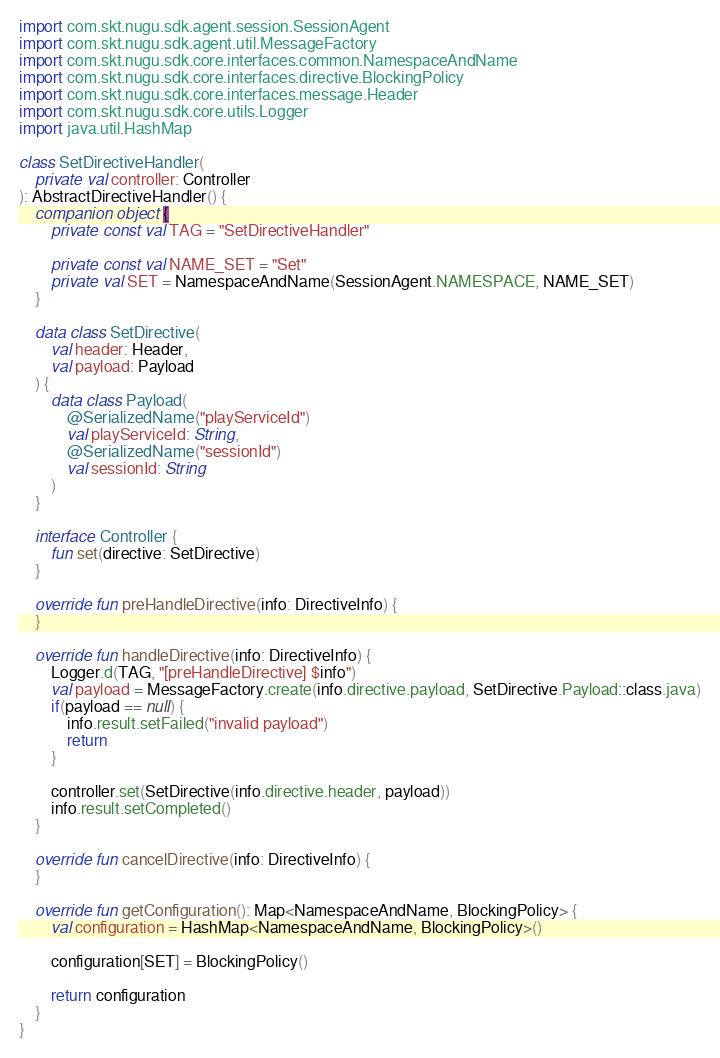<code> <loc_0><loc_0><loc_500><loc_500><_Kotlin_>import com.skt.nugu.sdk.agent.session.SessionAgent
import com.skt.nugu.sdk.agent.util.MessageFactory
import com.skt.nugu.sdk.core.interfaces.common.NamespaceAndName
import com.skt.nugu.sdk.core.interfaces.directive.BlockingPolicy
import com.skt.nugu.sdk.core.interfaces.message.Header
import com.skt.nugu.sdk.core.utils.Logger
import java.util.HashMap

class SetDirectiveHandler(
    private val controller: Controller
): AbstractDirectiveHandler() {
    companion object {
        private const val TAG = "SetDirectiveHandler"

        private const val NAME_SET = "Set"
        private val SET = NamespaceAndName(SessionAgent.NAMESPACE, NAME_SET)
    }

    data class SetDirective(
        val header: Header,
        val payload: Payload
    ) {
        data class Payload(
            @SerializedName("playServiceId")
            val playServiceId: String,
            @SerializedName("sessionId")
            val sessionId: String
        )
    }

    interface Controller {
        fun set(directive: SetDirective)
    }

    override fun preHandleDirective(info: DirectiveInfo) {
    }

    override fun handleDirective(info: DirectiveInfo) {
        Logger.d(TAG, "[preHandleDirective] $info")
        val payload = MessageFactory.create(info.directive.payload, SetDirective.Payload::class.java)
        if(payload == null) {
            info.result.setFailed("invalid payload")
            return
        }

        controller.set(SetDirective(info.directive.header, payload))
        info.result.setCompleted()
    }

    override fun cancelDirective(info: DirectiveInfo) {
    }

    override fun getConfiguration(): Map<NamespaceAndName, BlockingPolicy> {
        val configuration = HashMap<NamespaceAndName, BlockingPolicy>()

        configuration[SET] = BlockingPolicy()

        return configuration
    }
}</code> 